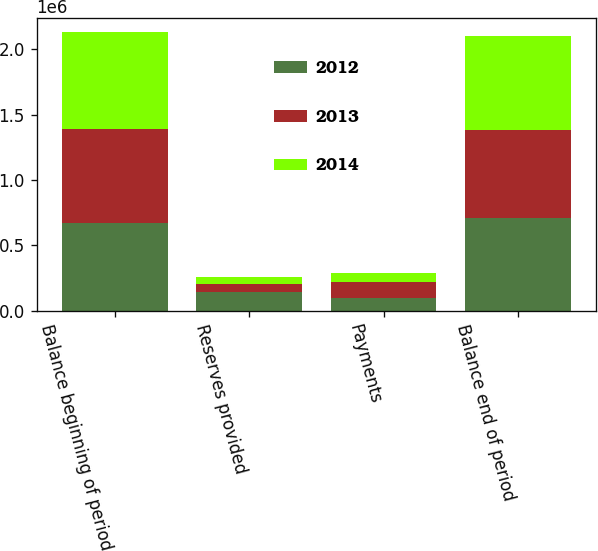<chart> <loc_0><loc_0><loc_500><loc_500><stacked_bar_chart><ecel><fcel>Balance beginning of period<fcel>Reserves provided<fcel>Payments<fcel>Balance end of period<nl><fcel>2012<fcel>668100<fcel>141790<fcel>99645<fcel>710245<nl><fcel>2013<fcel>721284<fcel>64737<fcel>117921<fcel>668100<nl><fcel>2014<fcel>739029<fcel>54262<fcel>72007<fcel>721284<nl></chart> 